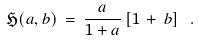Convert formula to latex. <formula><loc_0><loc_0><loc_500><loc_500>\mathfrak { H } ( a , b ) \, = \, \frac { a } { 1 + a } \, [ 1 \, + \, b ] \ .</formula> 